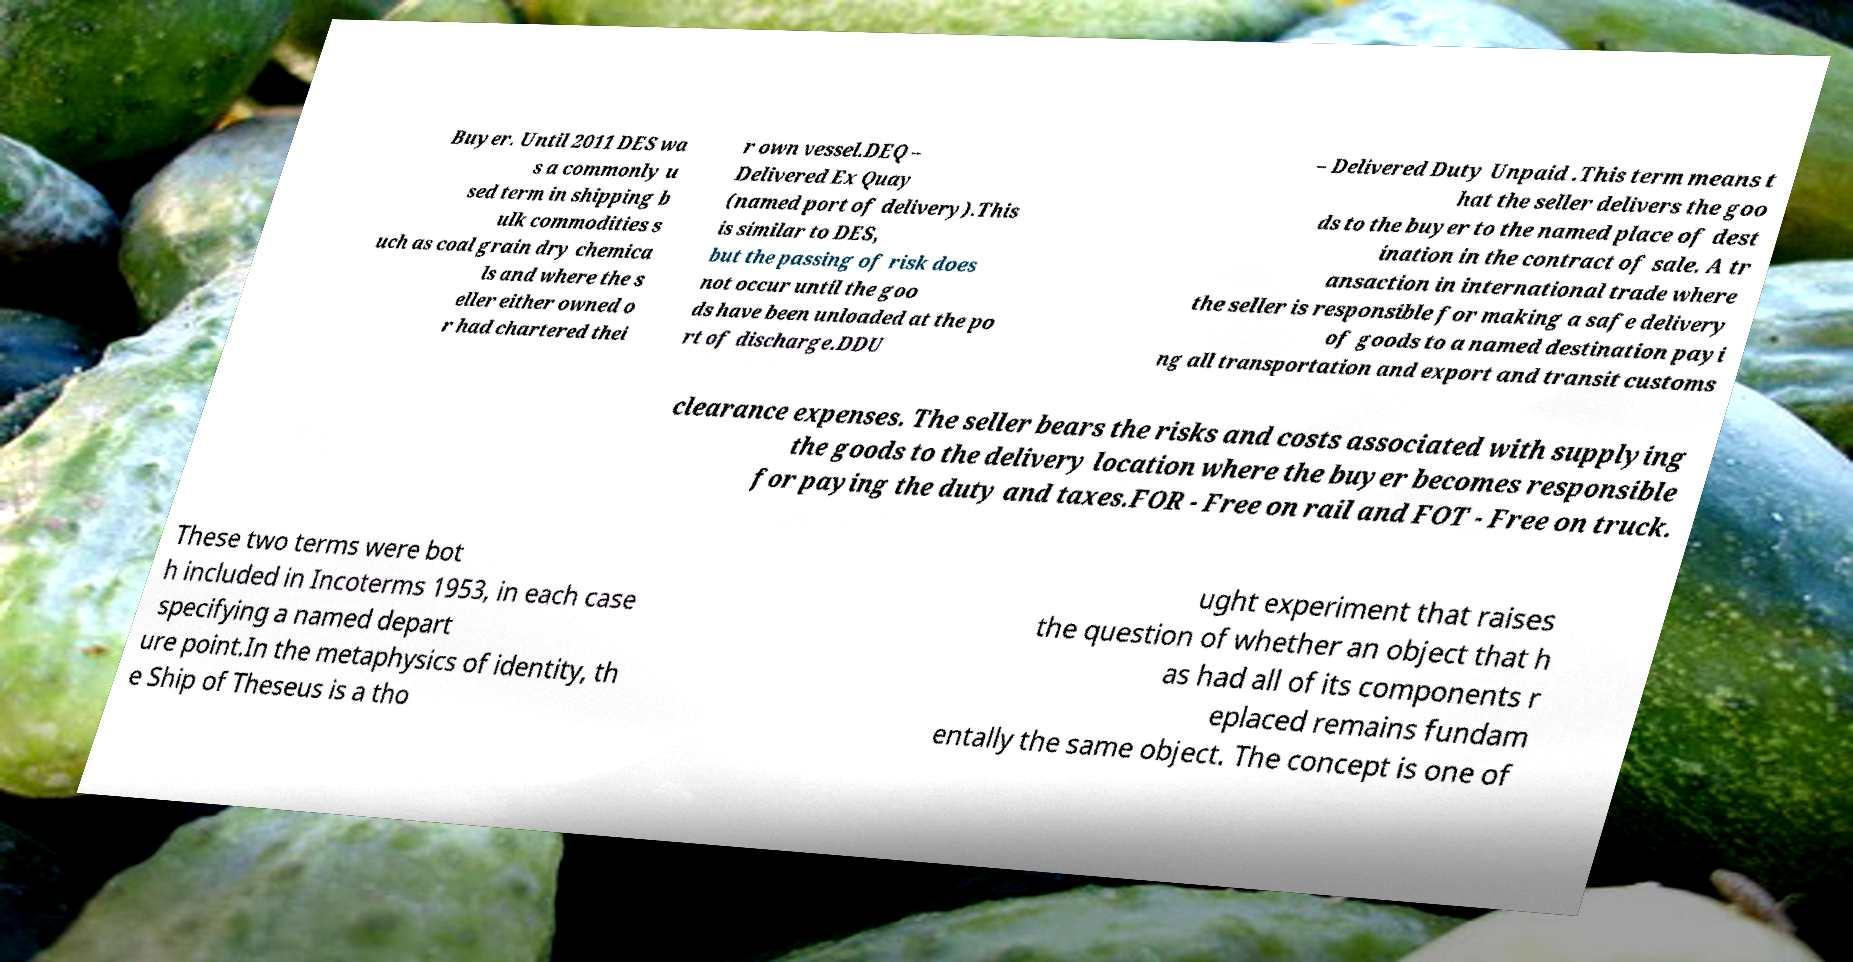Please identify and transcribe the text found in this image. Buyer. Until 2011 DES wa s a commonly u sed term in shipping b ulk commodities s uch as coal grain dry chemica ls and where the s eller either owned o r had chartered thei r own vessel.DEQ – Delivered Ex Quay (named port of delivery).This is similar to DES, but the passing of risk does not occur until the goo ds have been unloaded at the po rt of discharge.DDU – Delivered Duty Unpaid .This term means t hat the seller delivers the goo ds to the buyer to the named place of dest ination in the contract of sale. A tr ansaction in international trade where the seller is responsible for making a safe delivery of goods to a named destination payi ng all transportation and export and transit customs clearance expenses. The seller bears the risks and costs associated with supplying the goods to the delivery location where the buyer becomes responsible for paying the duty and taxes.FOR - Free on rail and FOT - Free on truck. These two terms were bot h included in Incoterms 1953, in each case specifying a named depart ure point.In the metaphysics of identity, th e Ship of Theseus is a tho ught experiment that raises the question of whether an object that h as had all of its components r eplaced remains fundam entally the same object. The concept is one of 